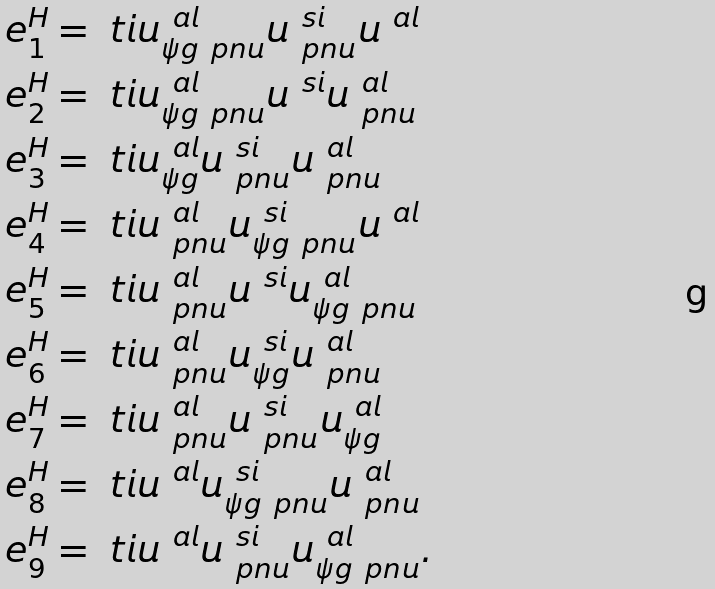<formula> <loc_0><loc_0><loc_500><loc_500>e ^ { H } _ { 1 } & = \ t i { u } ^ { \ a l } _ { \psi g \ p n u } u ^ { \ s i } _ { \ p n u } u ^ { \ a l } \\ e ^ { H } _ { 2 } & = \ t i { u } ^ { \ a l } _ { \psi g \ p n u } u ^ { \ s i } u ^ { \ a l } _ { \ p n u } \\ e ^ { H } _ { 3 } & = \ t i { u } ^ { \ a l } _ { \psi g } u ^ { \ s i } _ { \ p n u } u ^ { \ a l } _ { \ p n u } \\ e ^ { H } _ { 4 } & = \ t i { u } ^ { \ a l } _ { \ p n u } u ^ { \ s i } _ { \psi g \ p n u } u ^ { \ a l } \\ e ^ { H } _ { 5 } & = \ t i { u } ^ { \ a l } _ { \ p n u } u ^ { \ s i } u ^ { \ a l } _ { \psi g \ p n u } \\ e ^ { H } _ { 6 } & = \ t i { u } ^ { \ a l } _ { \ p n u } u ^ { \ s i } _ { \psi g } u ^ { \ a l } _ { \ p n u } \\ e ^ { H } _ { 7 } & = \ t i { u } ^ { \ a l } _ { \ p n u } u ^ { \ s i } _ { \ p n u } u ^ { \ a l } _ { \psi g } \\ e ^ { H } _ { 8 } & = \ t i { u } ^ { \ a l } u ^ { \ s i } _ { \psi g \ p n u } u ^ { \ a l } _ { \ p n u } \\ e ^ { H } _ { 9 } & = \ t i { u } ^ { \ a l } u ^ { \ s i } _ { \ p n u } u ^ { \ a l } _ { \psi g \ p n u } .</formula> 